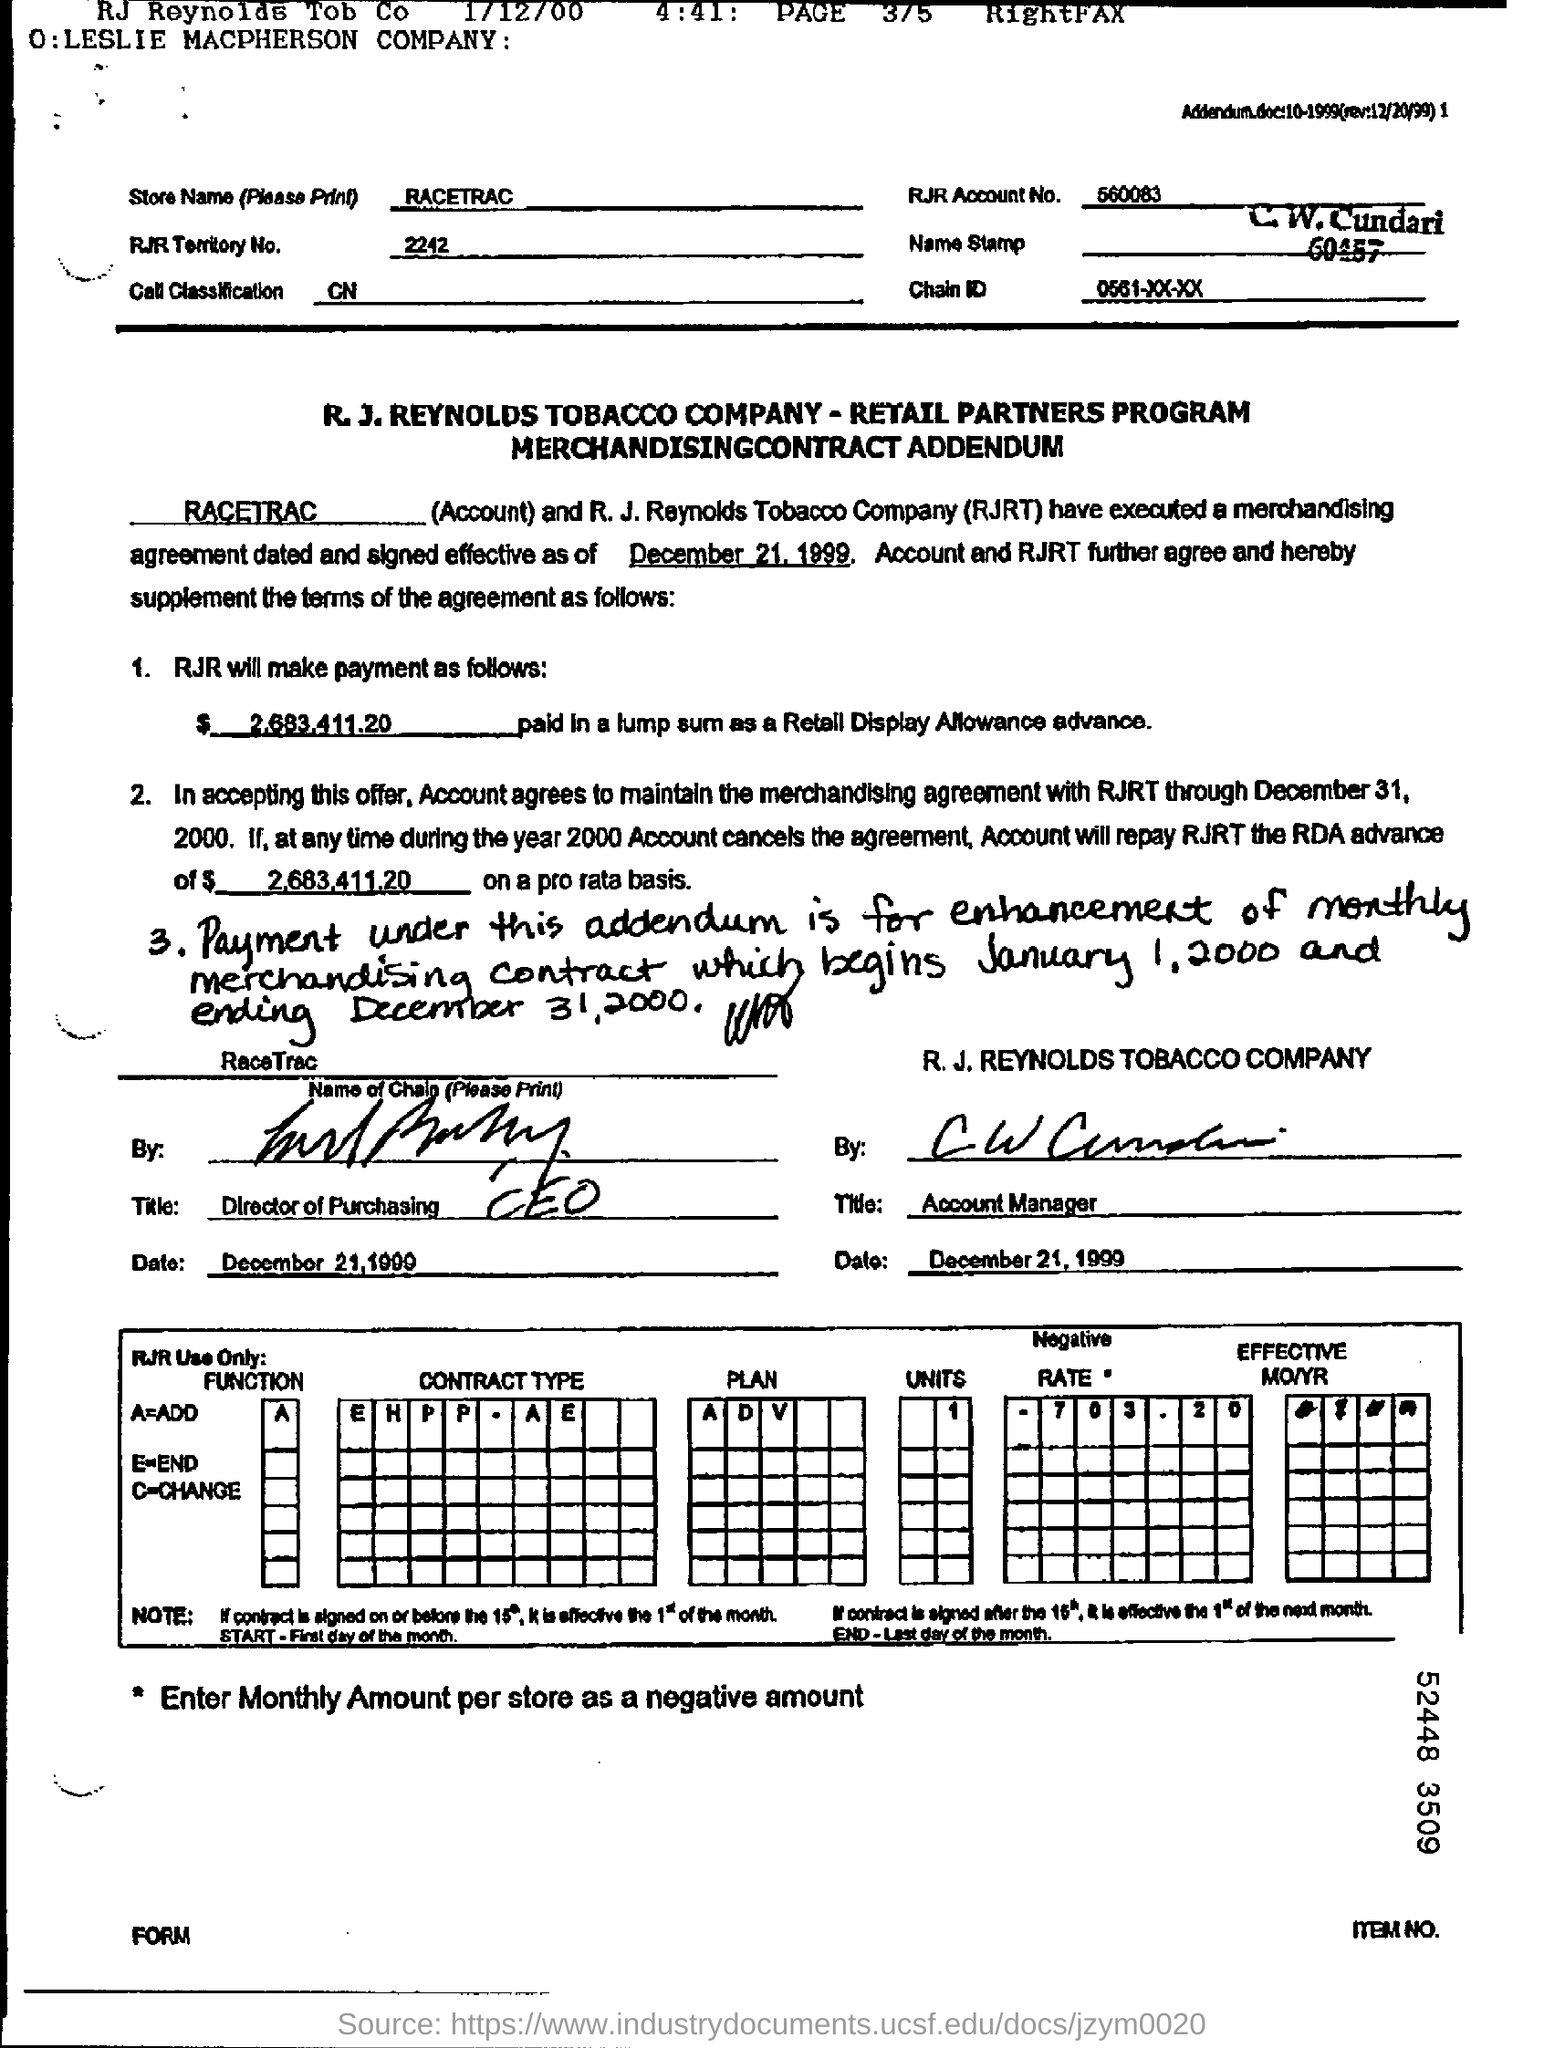Indicate a few pertinent items in this graphic. The store name is RACETRAC... The number 2242 belongs to RJR TERRITORY. 